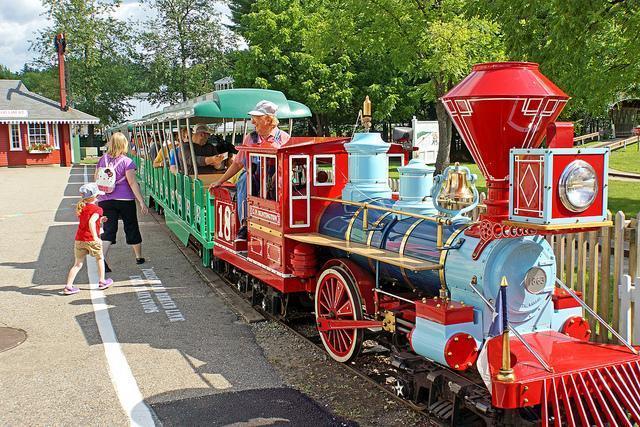How many people are headed towards the train?
Give a very brief answer. 2. How many people are visible?
Give a very brief answer. 2. How many cars are parked?
Give a very brief answer. 0. 